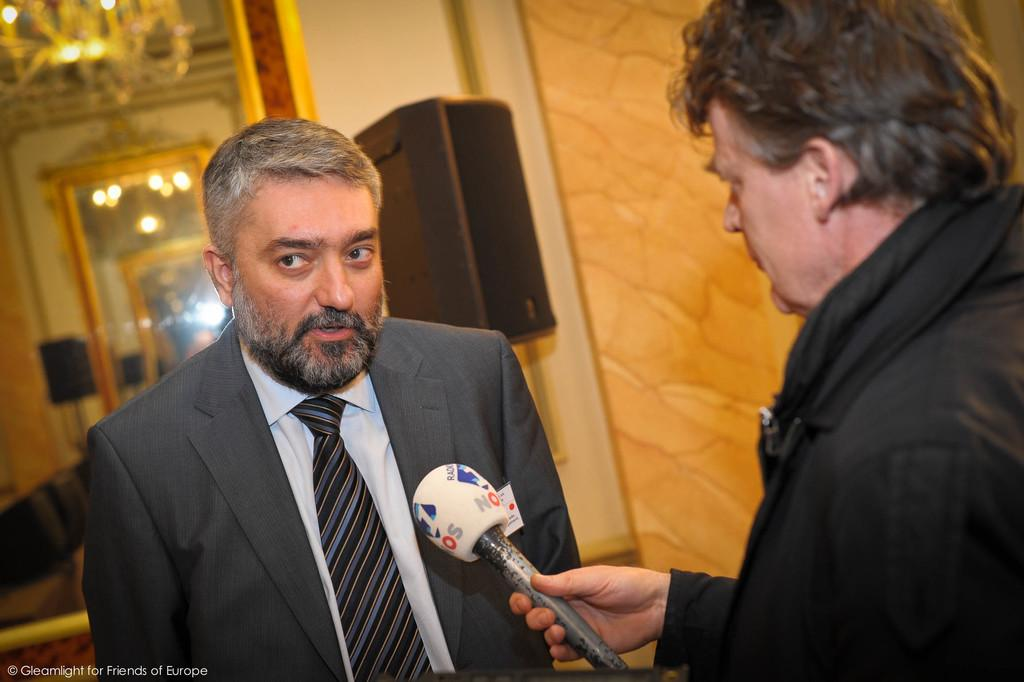What is the main subject of the image? There is a man standing in the image. What is the second man in the image doing? The second man is holding a microphone in the image. What can be seen in the background of the image? There is a wall and lights visible in the background of the image. Where is the sister sitting on the sofa in the image? There is no sister or sofa present in the image. How is the man measuring the distance between the lights in the image? There is no measuring or distance between lights mentioned in the image; the man is simply holding a microphone. 